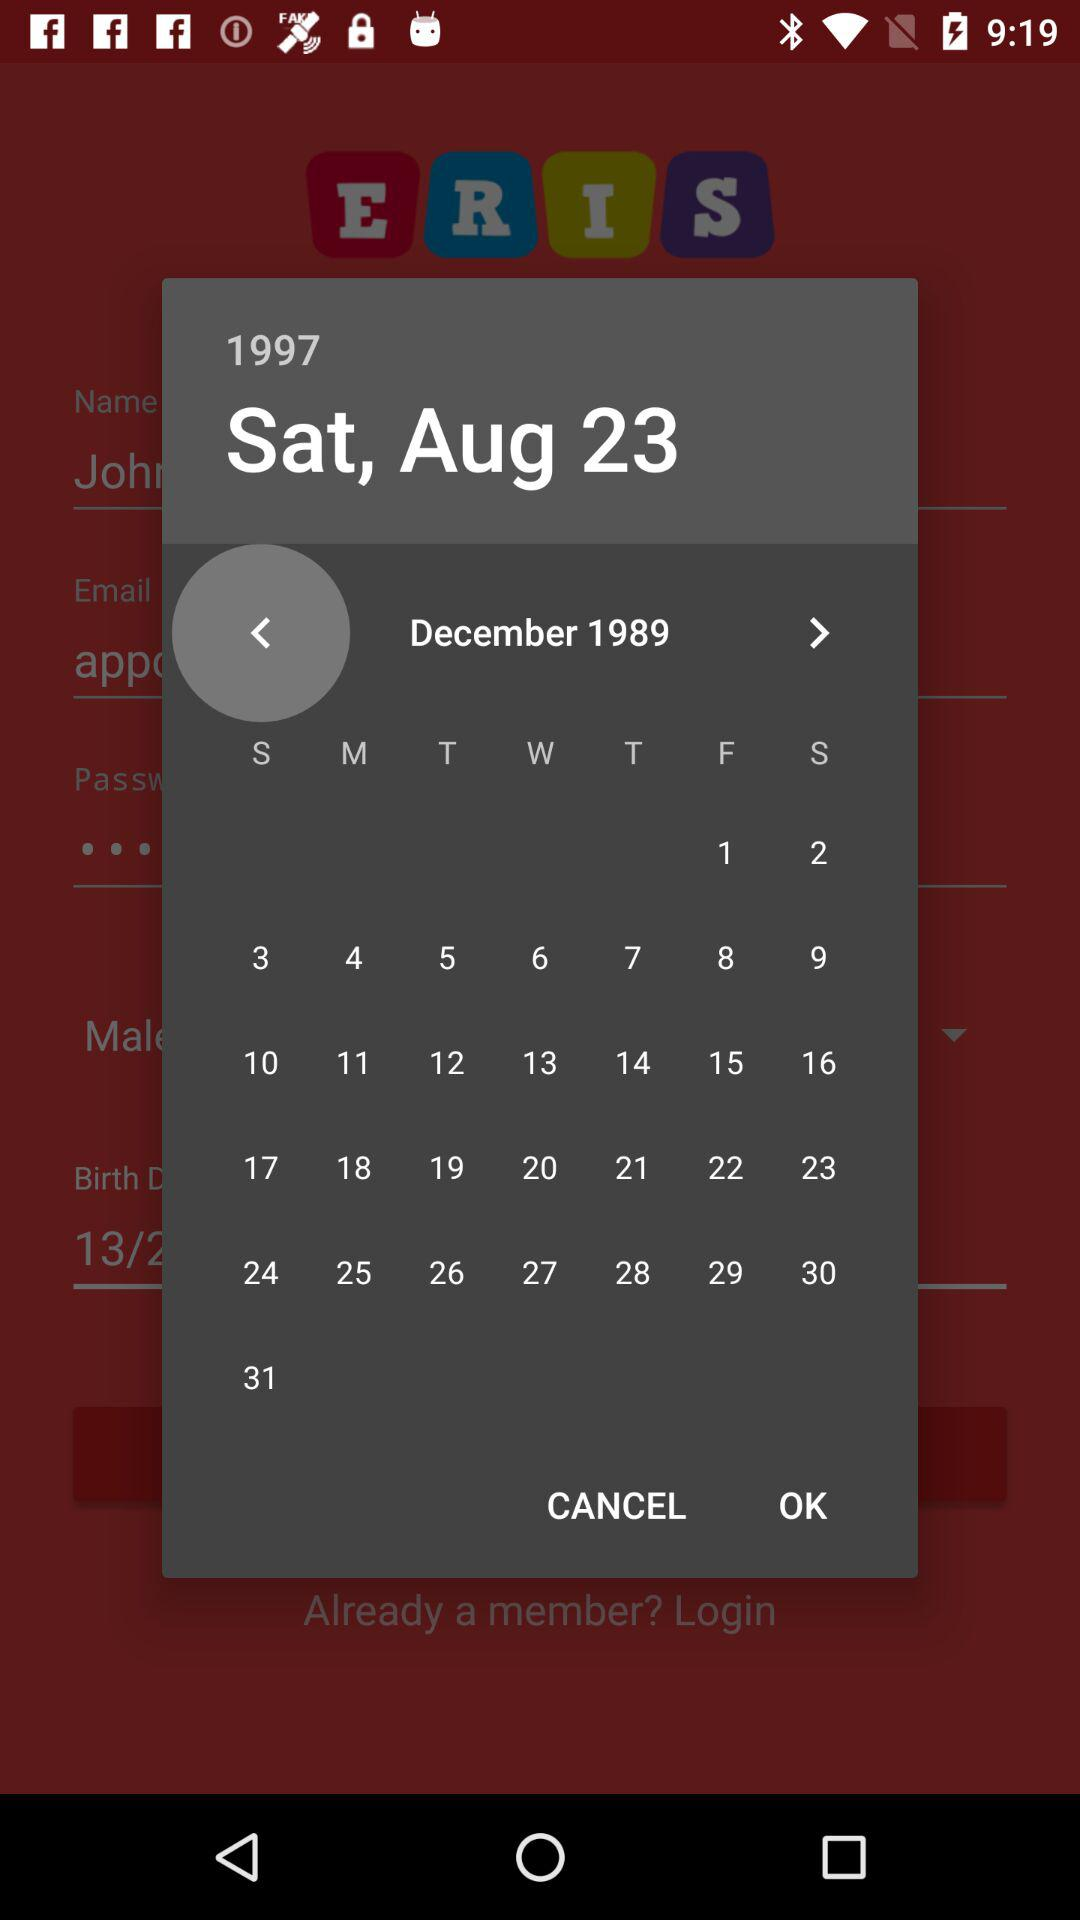What is the displayed year? The displayed years are 1997 and 1989. 